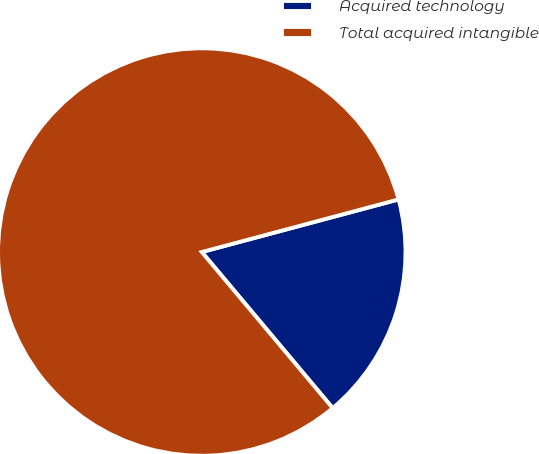<chart> <loc_0><loc_0><loc_500><loc_500><pie_chart><fcel>Acquired technology<fcel>Total acquired intangible<nl><fcel>18.05%<fcel>81.95%<nl></chart> 